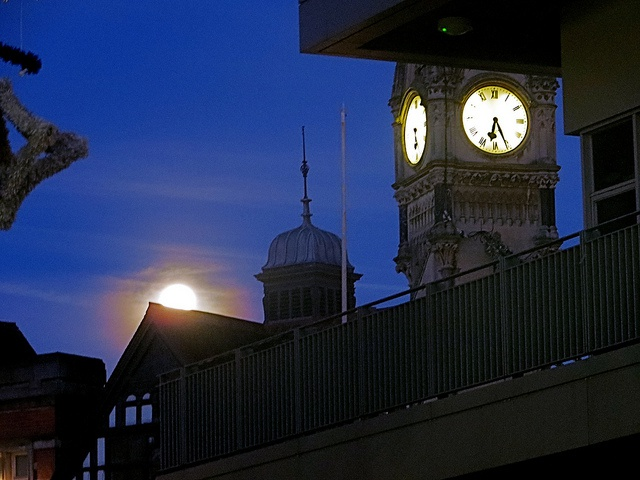Describe the objects in this image and their specific colors. I can see clock in navy, white, khaki, black, and olive tones and clock in navy, white, black, and olive tones in this image. 